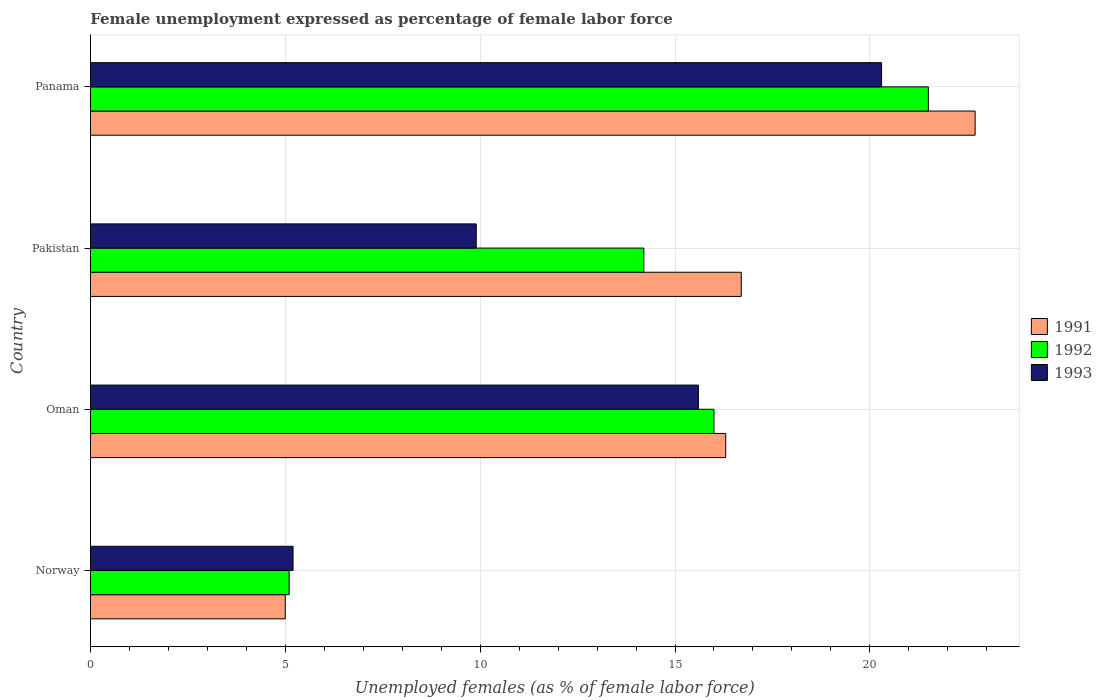Are the number of bars per tick equal to the number of legend labels?
Give a very brief answer. Yes. Are the number of bars on each tick of the Y-axis equal?
Make the answer very short. Yes. What is the label of the 3rd group of bars from the top?
Provide a succinct answer. Oman. What is the unemployment in females in in 1993 in Pakistan?
Your answer should be compact. 9.9. Across all countries, what is the minimum unemployment in females in in 1993?
Give a very brief answer. 5.2. In which country was the unemployment in females in in 1993 maximum?
Keep it short and to the point. Panama. In which country was the unemployment in females in in 1993 minimum?
Offer a very short reply. Norway. What is the total unemployment in females in in 1991 in the graph?
Your answer should be very brief. 60.7. What is the difference between the unemployment in females in in 1991 in Pakistan and that in Panama?
Your answer should be very brief. -6. What is the difference between the unemployment in females in in 1991 in Panama and the unemployment in females in in 1992 in Pakistan?
Your response must be concise. 8.5. What is the average unemployment in females in in 1993 per country?
Your answer should be very brief. 12.75. What is the difference between the unemployment in females in in 1993 and unemployment in females in in 1992 in Pakistan?
Ensure brevity in your answer.  -4.3. In how many countries, is the unemployment in females in in 1991 greater than 4 %?
Offer a terse response. 4. What is the ratio of the unemployment in females in in 1993 in Oman to that in Pakistan?
Make the answer very short. 1.58. Is the unemployment in females in in 1991 in Norway less than that in Panama?
Ensure brevity in your answer.  Yes. What is the difference between the highest and the second highest unemployment in females in in 1992?
Offer a very short reply. 5.5. What is the difference between the highest and the lowest unemployment in females in in 1993?
Your answer should be very brief. 15.1. Is the sum of the unemployment in females in in 1991 in Norway and Panama greater than the maximum unemployment in females in in 1993 across all countries?
Ensure brevity in your answer.  Yes. What does the 1st bar from the top in Oman represents?
Offer a terse response. 1993. Is it the case that in every country, the sum of the unemployment in females in in 1992 and unemployment in females in in 1993 is greater than the unemployment in females in in 1991?
Your answer should be compact. Yes. How many bars are there?
Offer a terse response. 12. Are the values on the major ticks of X-axis written in scientific E-notation?
Make the answer very short. No. Does the graph contain any zero values?
Offer a very short reply. No. Does the graph contain grids?
Offer a very short reply. Yes. Where does the legend appear in the graph?
Keep it short and to the point. Center right. How are the legend labels stacked?
Your answer should be very brief. Vertical. What is the title of the graph?
Provide a succinct answer. Female unemployment expressed as percentage of female labor force. What is the label or title of the X-axis?
Make the answer very short. Unemployed females (as % of female labor force). What is the Unemployed females (as % of female labor force) in 1991 in Norway?
Your answer should be compact. 5. What is the Unemployed females (as % of female labor force) of 1992 in Norway?
Provide a succinct answer. 5.1. What is the Unemployed females (as % of female labor force) in 1993 in Norway?
Offer a terse response. 5.2. What is the Unemployed females (as % of female labor force) of 1991 in Oman?
Ensure brevity in your answer.  16.3. What is the Unemployed females (as % of female labor force) of 1993 in Oman?
Offer a very short reply. 15.6. What is the Unemployed females (as % of female labor force) of 1991 in Pakistan?
Offer a very short reply. 16.7. What is the Unemployed females (as % of female labor force) of 1992 in Pakistan?
Ensure brevity in your answer.  14.2. What is the Unemployed females (as % of female labor force) in 1993 in Pakistan?
Your answer should be very brief. 9.9. What is the Unemployed females (as % of female labor force) of 1991 in Panama?
Ensure brevity in your answer.  22.7. What is the Unemployed females (as % of female labor force) in 1992 in Panama?
Offer a terse response. 21.5. What is the Unemployed females (as % of female labor force) of 1993 in Panama?
Provide a succinct answer. 20.3. Across all countries, what is the maximum Unemployed females (as % of female labor force) of 1991?
Offer a terse response. 22.7. Across all countries, what is the maximum Unemployed females (as % of female labor force) of 1993?
Your answer should be very brief. 20.3. Across all countries, what is the minimum Unemployed females (as % of female labor force) in 1991?
Your answer should be compact. 5. Across all countries, what is the minimum Unemployed females (as % of female labor force) in 1992?
Provide a short and direct response. 5.1. Across all countries, what is the minimum Unemployed females (as % of female labor force) in 1993?
Offer a very short reply. 5.2. What is the total Unemployed females (as % of female labor force) of 1991 in the graph?
Provide a succinct answer. 60.7. What is the total Unemployed females (as % of female labor force) of 1992 in the graph?
Your response must be concise. 56.8. What is the total Unemployed females (as % of female labor force) in 1993 in the graph?
Make the answer very short. 51. What is the difference between the Unemployed females (as % of female labor force) of 1991 in Norway and that in Oman?
Offer a terse response. -11.3. What is the difference between the Unemployed females (as % of female labor force) in 1991 in Norway and that in Pakistan?
Keep it short and to the point. -11.7. What is the difference between the Unemployed females (as % of female labor force) of 1992 in Norway and that in Pakistan?
Your answer should be very brief. -9.1. What is the difference between the Unemployed females (as % of female labor force) of 1993 in Norway and that in Pakistan?
Your response must be concise. -4.7. What is the difference between the Unemployed females (as % of female labor force) of 1991 in Norway and that in Panama?
Make the answer very short. -17.7. What is the difference between the Unemployed females (as % of female labor force) of 1992 in Norway and that in Panama?
Make the answer very short. -16.4. What is the difference between the Unemployed females (as % of female labor force) of 1993 in Norway and that in Panama?
Keep it short and to the point. -15.1. What is the difference between the Unemployed females (as % of female labor force) in 1993 in Oman and that in Panama?
Ensure brevity in your answer.  -4.7. What is the difference between the Unemployed females (as % of female labor force) of 1991 in Norway and the Unemployed females (as % of female labor force) of 1992 in Oman?
Offer a terse response. -11. What is the difference between the Unemployed females (as % of female labor force) of 1991 in Norway and the Unemployed females (as % of female labor force) of 1992 in Pakistan?
Offer a terse response. -9.2. What is the difference between the Unemployed females (as % of female labor force) of 1992 in Norway and the Unemployed females (as % of female labor force) of 1993 in Pakistan?
Provide a succinct answer. -4.8. What is the difference between the Unemployed females (as % of female labor force) of 1991 in Norway and the Unemployed females (as % of female labor force) of 1992 in Panama?
Your answer should be very brief. -16.5. What is the difference between the Unemployed females (as % of female labor force) of 1991 in Norway and the Unemployed females (as % of female labor force) of 1993 in Panama?
Offer a very short reply. -15.3. What is the difference between the Unemployed females (as % of female labor force) of 1992 in Norway and the Unemployed females (as % of female labor force) of 1993 in Panama?
Make the answer very short. -15.2. What is the difference between the Unemployed females (as % of female labor force) of 1991 in Oman and the Unemployed females (as % of female labor force) of 1992 in Pakistan?
Your answer should be very brief. 2.1. What is the difference between the Unemployed females (as % of female labor force) in 1991 in Oman and the Unemployed females (as % of female labor force) in 1993 in Pakistan?
Give a very brief answer. 6.4. What is the difference between the Unemployed females (as % of female labor force) in 1992 in Oman and the Unemployed females (as % of female labor force) in 1993 in Pakistan?
Keep it short and to the point. 6.1. What is the difference between the Unemployed females (as % of female labor force) in 1991 in Oman and the Unemployed females (as % of female labor force) in 1992 in Panama?
Make the answer very short. -5.2. What is the difference between the Unemployed females (as % of female labor force) in 1992 in Oman and the Unemployed females (as % of female labor force) in 1993 in Panama?
Keep it short and to the point. -4.3. What is the difference between the Unemployed females (as % of female labor force) in 1992 in Pakistan and the Unemployed females (as % of female labor force) in 1993 in Panama?
Give a very brief answer. -6.1. What is the average Unemployed females (as % of female labor force) in 1991 per country?
Ensure brevity in your answer.  15.18. What is the average Unemployed females (as % of female labor force) of 1992 per country?
Offer a terse response. 14.2. What is the average Unemployed females (as % of female labor force) in 1993 per country?
Provide a succinct answer. 12.75. What is the difference between the Unemployed females (as % of female labor force) of 1991 and Unemployed females (as % of female labor force) of 1992 in Norway?
Offer a very short reply. -0.1. What is the difference between the Unemployed females (as % of female labor force) in 1991 and Unemployed females (as % of female labor force) in 1992 in Oman?
Your answer should be very brief. 0.3. What is the difference between the Unemployed females (as % of female labor force) of 1991 and Unemployed females (as % of female labor force) of 1993 in Oman?
Your answer should be very brief. 0.7. What is the difference between the Unemployed females (as % of female labor force) of 1992 and Unemployed females (as % of female labor force) of 1993 in Oman?
Provide a succinct answer. 0.4. What is the difference between the Unemployed females (as % of female labor force) in 1991 and Unemployed females (as % of female labor force) in 1992 in Pakistan?
Offer a terse response. 2.5. What is the difference between the Unemployed females (as % of female labor force) of 1991 and Unemployed females (as % of female labor force) of 1993 in Pakistan?
Your answer should be compact. 6.8. What is the difference between the Unemployed females (as % of female labor force) of 1992 and Unemployed females (as % of female labor force) of 1993 in Panama?
Provide a short and direct response. 1.2. What is the ratio of the Unemployed females (as % of female labor force) of 1991 in Norway to that in Oman?
Your answer should be compact. 0.31. What is the ratio of the Unemployed females (as % of female labor force) in 1992 in Norway to that in Oman?
Ensure brevity in your answer.  0.32. What is the ratio of the Unemployed females (as % of female labor force) in 1991 in Norway to that in Pakistan?
Keep it short and to the point. 0.3. What is the ratio of the Unemployed females (as % of female labor force) of 1992 in Norway to that in Pakistan?
Your response must be concise. 0.36. What is the ratio of the Unemployed females (as % of female labor force) in 1993 in Norway to that in Pakistan?
Your response must be concise. 0.53. What is the ratio of the Unemployed females (as % of female labor force) of 1991 in Norway to that in Panama?
Give a very brief answer. 0.22. What is the ratio of the Unemployed females (as % of female labor force) of 1992 in Norway to that in Panama?
Keep it short and to the point. 0.24. What is the ratio of the Unemployed females (as % of female labor force) of 1993 in Norway to that in Panama?
Offer a very short reply. 0.26. What is the ratio of the Unemployed females (as % of female labor force) of 1991 in Oman to that in Pakistan?
Provide a short and direct response. 0.98. What is the ratio of the Unemployed females (as % of female labor force) in 1992 in Oman to that in Pakistan?
Offer a very short reply. 1.13. What is the ratio of the Unemployed females (as % of female labor force) in 1993 in Oman to that in Pakistan?
Provide a succinct answer. 1.58. What is the ratio of the Unemployed females (as % of female labor force) of 1991 in Oman to that in Panama?
Provide a short and direct response. 0.72. What is the ratio of the Unemployed females (as % of female labor force) in 1992 in Oman to that in Panama?
Give a very brief answer. 0.74. What is the ratio of the Unemployed females (as % of female labor force) in 1993 in Oman to that in Panama?
Make the answer very short. 0.77. What is the ratio of the Unemployed females (as % of female labor force) in 1991 in Pakistan to that in Panama?
Your answer should be very brief. 0.74. What is the ratio of the Unemployed females (as % of female labor force) in 1992 in Pakistan to that in Panama?
Provide a succinct answer. 0.66. What is the ratio of the Unemployed females (as % of female labor force) of 1993 in Pakistan to that in Panama?
Offer a very short reply. 0.49. What is the difference between the highest and the second highest Unemployed females (as % of female labor force) in 1991?
Your response must be concise. 6. What is the difference between the highest and the lowest Unemployed females (as % of female labor force) of 1993?
Offer a very short reply. 15.1. 